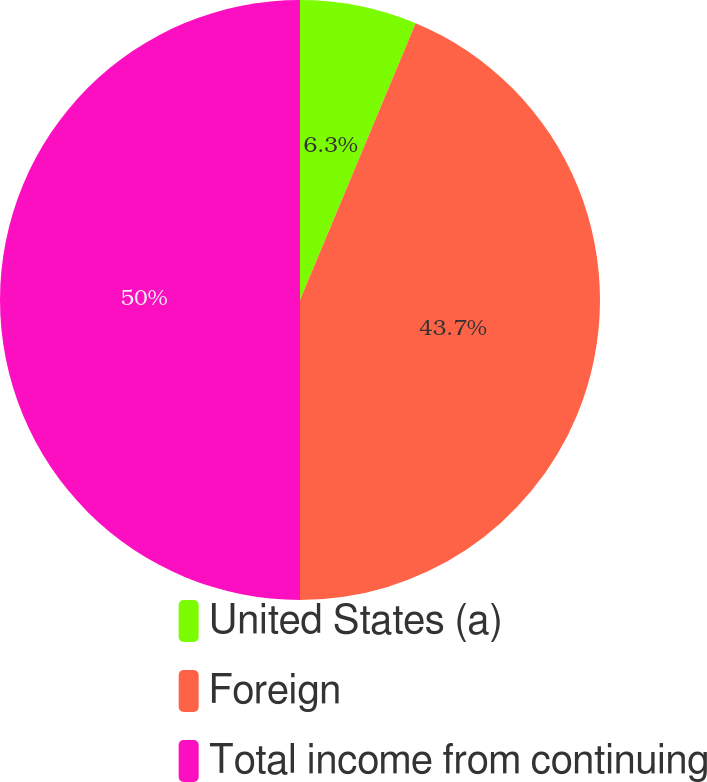Convert chart. <chart><loc_0><loc_0><loc_500><loc_500><pie_chart><fcel>United States (a)<fcel>Foreign<fcel>Total income from continuing<nl><fcel>6.3%<fcel>43.7%<fcel>50.0%<nl></chart> 